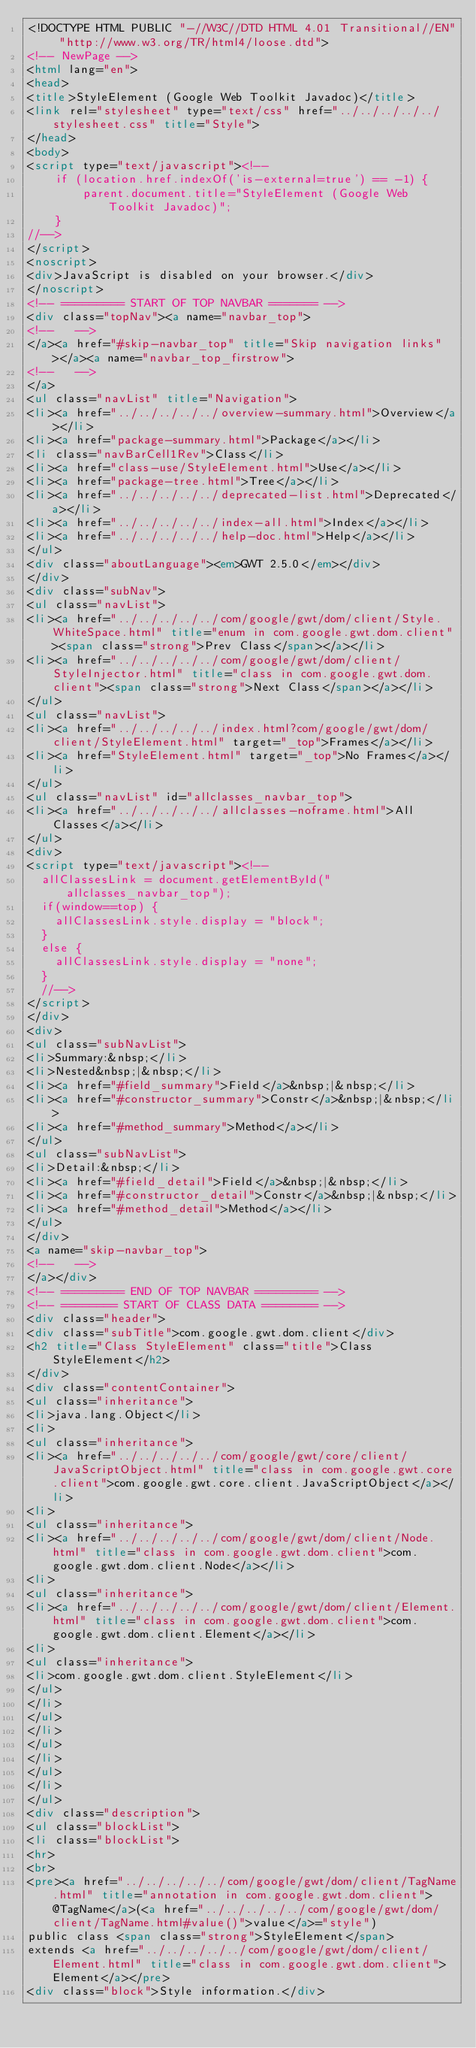Convert code to text. <code><loc_0><loc_0><loc_500><loc_500><_HTML_><!DOCTYPE HTML PUBLIC "-//W3C//DTD HTML 4.01 Transitional//EN" "http://www.w3.org/TR/html4/loose.dtd">
<!-- NewPage -->
<html lang="en">
<head>
<title>StyleElement (Google Web Toolkit Javadoc)</title>
<link rel="stylesheet" type="text/css" href="../../../../../stylesheet.css" title="Style">
</head>
<body>
<script type="text/javascript"><!--
    if (location.href.indexOf('is-external=true') == -1) {
        parent.document.title="StyleElement (Google Web Toolkit Javadoc)";
    }
//-->
</script>
<noscript>
<div>JavaScript is disabled on your browser.</div>
</noscript>
<!-- ========= START OF TOP NAVBAR ======= -->
<div class="topNav"><a name="navbar_top">
<!--   -->
</a><a href="#skip-navbar_top" title="Skip navigation links"></a><a name="navbar_top_firstrow">
<!--   -->
</a>
<ul class="navList" title="Navigation">
<li><a href="../../../../../overview-summary.html">Overview</a></li>
<li><a href="package-summary.html">Package</a></li>
<li class="navBarCell1Rev">Class</li>
<li><a href="class-use/StyleElement.html">Use</a></li>
<li><a href="package-tree.html">Tree</a></li>
<li><a href="../../../../../deprecated-list.html">Deprecated</a></li>
<li><a href="../../../../../index-all.html">Index</a></li>
<li><a href="../../../../../help-doc.html">Help</a></li>
</ul>
<div class="aboutLanguage"><em>GWT 2.5.0</em></div>
</div>
<div class="subNav">
<ul class="navList">
<li><a href="../../../../../com/google/gwt/dom/client/Style.WhiteSpace.html" title="enum in com.google.gwt.dom.client"><span class="strong">Prev Class</span></a></li>
<li><a href="../../../../../com/google/gwt/dom/client/StyleInjector.html" title="class in com.google.gwt.dom.client"><span class="strong">Next Class</span></a></li>
</ul>
<ul class="navList">
<li><a href="../../../../../index.html?com/google/gwt/dom/client/StyleElement.html" target="_top">Frames</a></li>
<li><a href="StyleElement.html" target="_top">No Frames</a></li>
</ul>
<ul class="navList" id="allclasses_navbar_top">
<li><a href="../../../../../allclasses-noframe.html">All Classes</a></li>
</ul>
<div>
<script type="text/javascript"><!--
  allClassesLink = document.getElementById("allclasses_navbar_top");
  if(window==top) {
    allClassesLink.style.display = "block";
  }
  else {
    allClassesLink.style.display = "none";
  }
  //-->
</script>
</div>
<div>
<ul class="subNavList">
<li>Summary:&nbsp;</li>
<li>Nested&nbsp;|&nbsp;</li>
<li><a href="#field_summary">Field</a>&nbsp;|&nbsp;</li>
<li><a href="#constructor_summary">Constr</a>&nbsp;|&nbsp;</li>
<li><a href="#method_summary">Method</a></li>
</ul>
<ul class="subNavList">
<li>Detail:&nbsp;</li>
<li><a href="#field_detail">Field</a>&nbsp;|&nbsp;</li>
<li><a href="#constructor_detail">Constr</a>&nbsp;|&nbsp;</li>
<li><a href="#method_detail">Method</a></li>
</ul>
</div>
<a name="skip-navbar_top">
<!--   -->
</a></div>
<!-- ========= END OF TOP NAVBAR ========= -->
<!-- ======== START OF CLASS DATA ======== -->
<div class="header">
<div class="subTitle">com.google.gwt.dom.client</div>
<h2 title="Class StyleElement" class="title">Class StyleElement</h2>
</div>
<div class="contentContainer">
<ul class="inheritance">
<li>java.lang.Object</li>
<li>
<ul class="inheritance">
<li><a href="../../../../../com/google/gwt/core/client/JavaScriptObject.html" title="class in com.google.gwt.core.client">com.google.gwt.core.client.JavaScriptObject</a></li>
<li>
<ul class="inheritance">
<li><a href="../../../../../com/google/gwt/dom/client/Node.html" title="class in com.google.gwt.dom.client">com.google.gwt.dom.client.Node</a></li>
<li>
<ul class="inheritance">
<li><a href="../../../../../com/google/gwt/dom/client/Element.html" title="class in com.google.gwt.dom.client">com.google.gwt.dom.client.Element</a></li>
<li>
<ul class="inheritance">
<li>com.google.gwt.dom.client.StyleElement</li>
</ul>
</li>
</ul>
</li>
</ul>
</li>
</ul>
</li>
</ul>
<div class="description">
<ul class="blockList">
<li class="blockList">
<hr>
<br>
<pre><a href="../../../../../com/google/gwt/dom/client/TagName.html" title="annotation in com.google.gwt.dom.client">@TagName</a>(<a href="../../../../../com/google/gwt/dom/client/TagName.html#value()">value</a>="style")
public class <span class="strong">StyleElement</span>
extends <a href="../../../../../com/google/gwt/dom/client/Element.html" title="class in com.google.gwt.dom.client">Element</a></pre>
<div class="block">Style information.</div></code> 